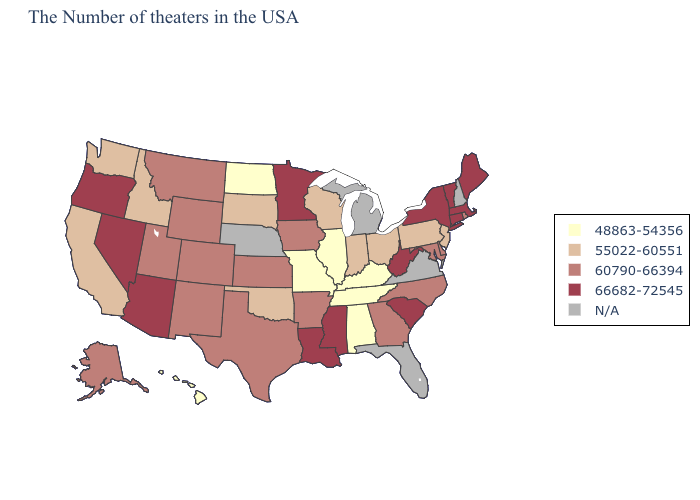Name the states that have a value in the range 55022-60551?
Keep it brief. New Jersey, Pennsylvania, Ohio, Indiana, Wisconsin, Oklahoma, South Dakota, Idaho, California, Washington. Which states have the lowest value in the USA?
Concise answer only. Kentucky, Alabama, Tennessee, Illinois, Missouri, North Dakota, Hawaii. Does Arkansas have the lowest value in the USA?
Give a very brief answer. No. What is the value of Arkansas?
Answer briefly. 60790-66394. Name the states that have a value in the range 48863-54356?
Quick response, please. Kentucky, Alabama, Tennessee, Illinois, Missouri, North Dakota, Hawaii. Which states have the lowest value in the South?
Quick response, please. Kentucky, Alabama, Tennessee. Which states have the highest value in the USA?
Give a very brief answer. Maine, Massachusetts, Vermont, Connecticut, New York, South Carolina, West Virginia, Mississippi, Louisiana, Minnesota, Arizona, Nevada, Oregon. Does the first symbol in the legend represent the smallest category?
Quick response, please. Yes. Does Alabama have the lowest value in the USA?
Give a very brief answer. Yes. What is the value of Georgia?
Answer briefly. 60790-66394. Name the states that have a value in the range 66682-72545?
Answer briefly. Maine, Massachusetts, Vermont, Connecticut, New York, South Carolina, West Virginia, Mississippi, Louisiana, Minnesota, Arizona, Nevada, Oregon. What is the highest value in the South ?
Short answer required. 66682-72545. Does the first symbol in the legend represent the smallest category?
Concise answer only. Yes. Name the states that have a value in the range 48863-54356?
Be succinct. Kentucky, Alabama, Tennessee, Illinois, Missouri, North Dakota, Hawaii. 